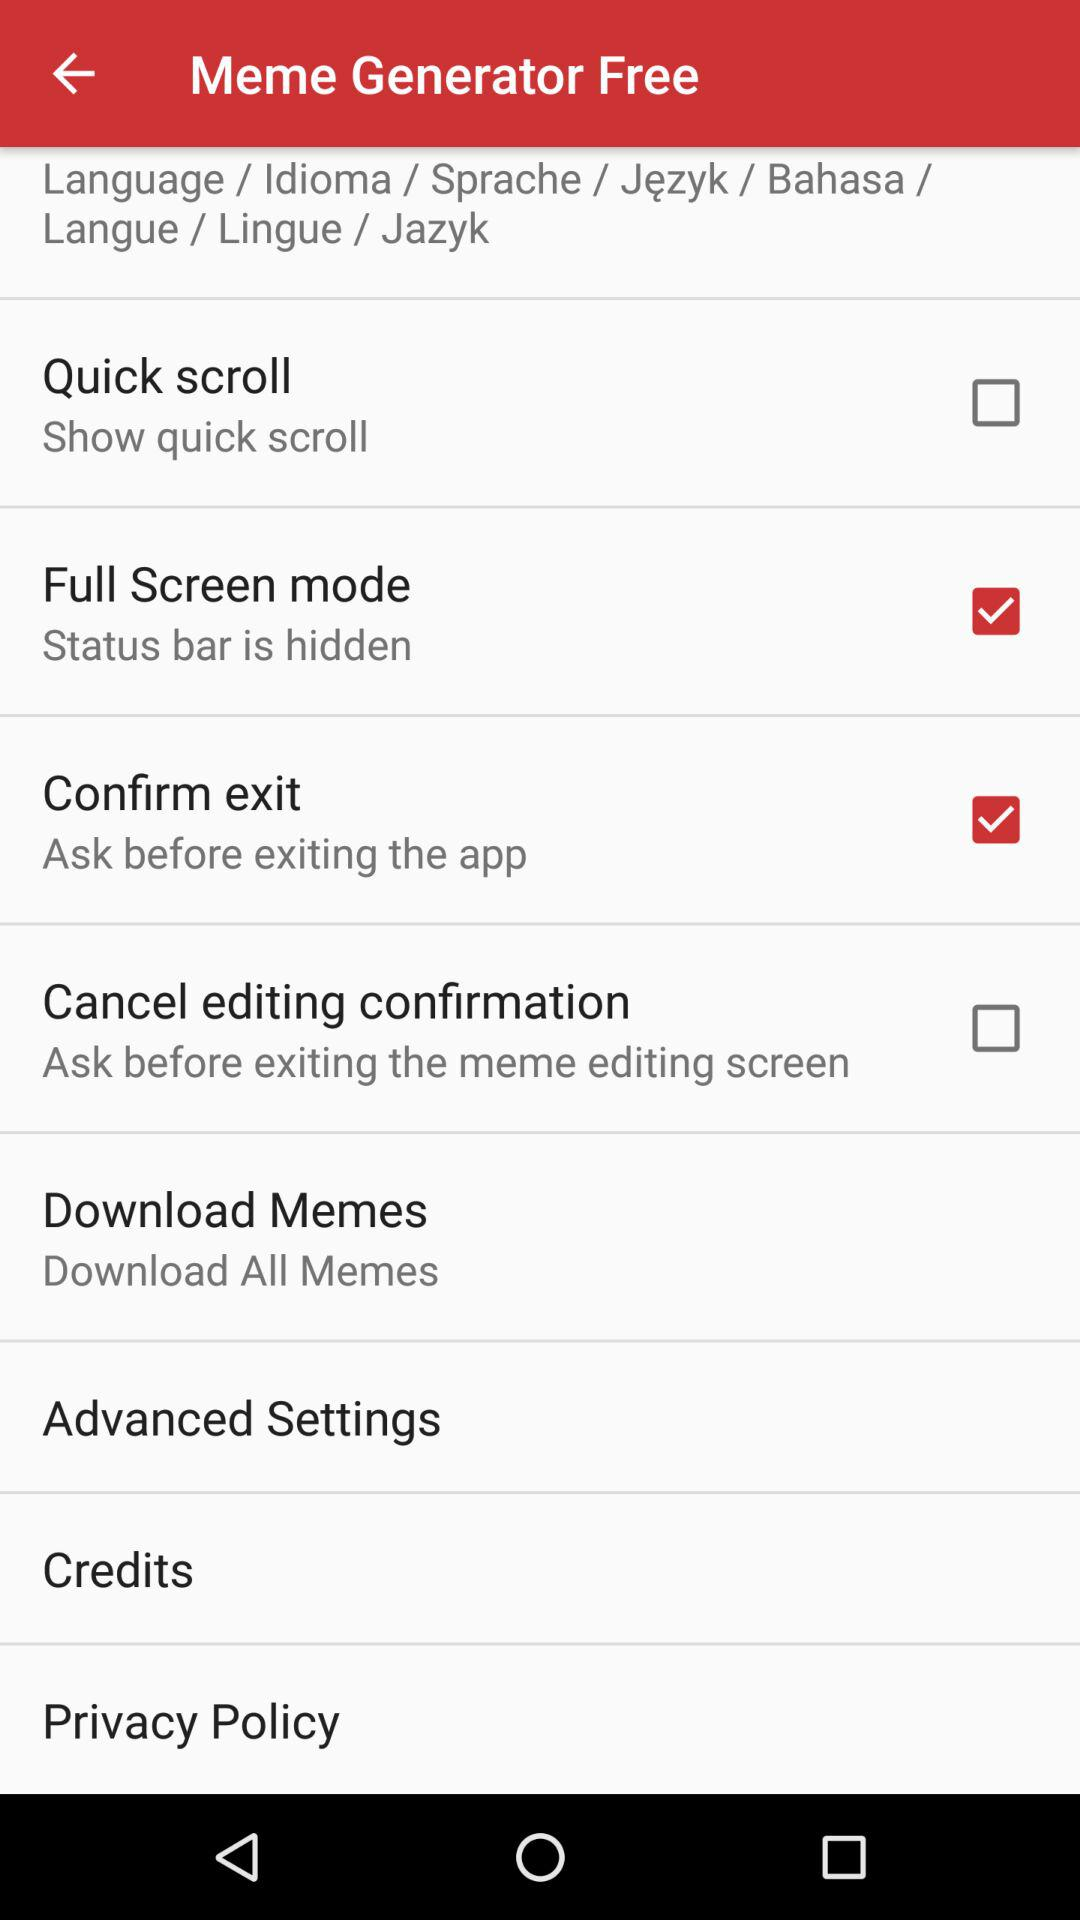What is the status of the "Confirm Exit"? The status is on. 